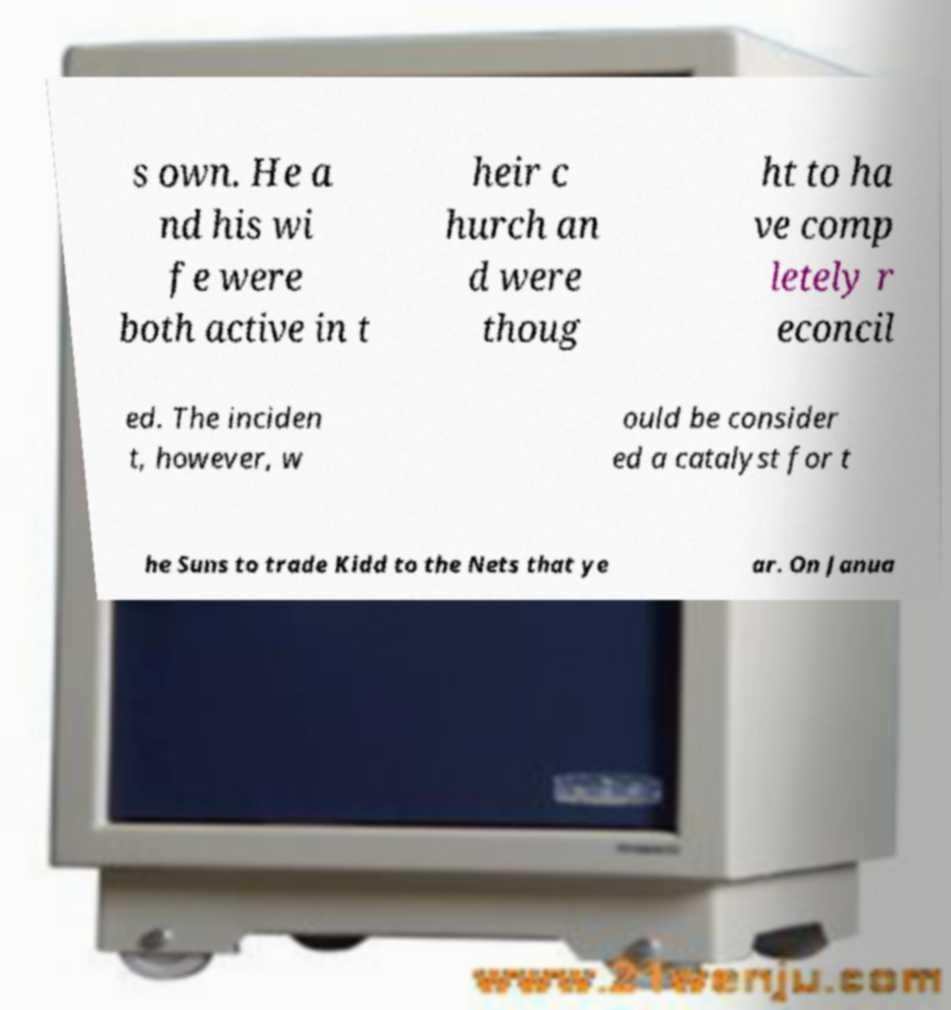Could you assist in decoding the text presented in this image and type it out clearly? s own. He a nd his wi fe were both active in t heir c hurch an d were thoug ht to ha ve comp letely r econcil ed. The inciden t, however, w ould be consider ed a catalyst for t he Suns to trade Kidd to the Nets that ye ar. On Janua 